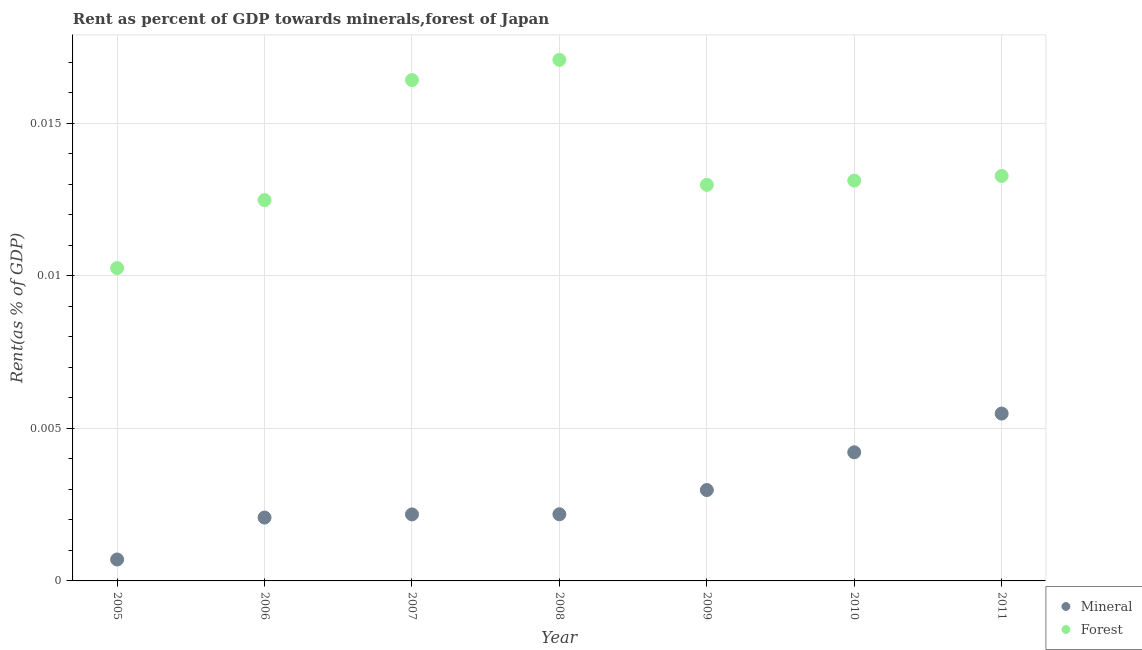What is the mineral rent in 2009?
Your answer should be very brief. 0. Across all years, what is the maximum mineral rent?
Keep it short and to the point. 0.01. Across all years, what is the minimum mineral rent?
Your response must be concise. 0. In which year was the mineral rent minimum?
Offer a terse response. 2005. What is the total forest rent in the graph?
Provide a succinct answer. 0.1. What is the difference between the forest rent in 2007 and that in 2010?
Your answer should be compact. 0. What is the difference between the forest rent in 2011 and the mineral rent in 2005?
Your answer should be compact. 0.01. What is the average mineral rent per year?
Provide a succinct answer. 0. In the year 2006, what is the difference between the forest rent and mineral rent?
Ensure brevity in your answer.  0.01. In how many years, is the forest rent greater than 0.007 %?
Make the answer very short. 7. What is the ratio of the forest rent in 2006 to that in 2011?
Your response must be concise. 0.94. Is the forest rent in 2007 less than that in 2009?
Provide a succinct answer. No. Is the difference between the mineral rent in 2008 and 2011 greater than the difference between the forest rent in 2008 and 2011?
Make the answer very short. No. What is the difference between the highest and the second highest mineral rent?
Provide a short and direct response. 0. What is the difference between the highest and the lowest forest rent?
Your answer should be very brief. 0.01. Does the mineral rent monotonically increase over the years?
Offer a very short reply. Yes. Is the mineral rent strictly greater than the forest rent over the years?
Offer a very short reply. No. How many years are there in the graph?
Give a very brief answer. 7. What is the difference between two consecutive major ticks on the Y-axis?
Provide a short and direct response. 0.01. Are the values on the major ticks of Y-axis written in scientific E-notation?
Provide a succinct answer. No. Does the graph contain any zero values?
Give a very brief answer. No. Does the graph contain grids?
Ensure brevity in your answer.  Yes. What is the title of the graph?
Your answer should be very brief. Rent as percent of GDP towards minerals,forest of Japan. Does "Agricultural land" appear as one of the legend labels in the graph?
Offer a terse response. No. What is the label or title of the X-axis?
Offer a terse response. Year. What is the label or title of the Y-axis?
Your answer should be very brief. Rent(as % of GDP). What is the Rent(as % of GDP) of Mineral in 2005?
Your answer should be very brief. 0. What is the Rent(as % of GDP) in Forest in 2005?
Your answer should be very brief. 0.01. What is the Rent(as % of GDP) of Mineral in 2006?
Offer a terse response. 0. What is the Rent(as % of GDP) of Forest in 2006?
Your answer should be very brief. 0.01. What is the Rent(as % of GDP) in Mineral in 2007?
Your answer should be very brief. 0. What is the Rent(as % of GDP) of Forest in 2007?
Your answer should be very brief. 0.02. What is the Rent(as % of GDP) of Mineral in 2008?
Your response must be concise. 0. What is the Rent(as % of GDP) of Forest in 2008?
Make the answer very short. 0.02. What is the Rent(as % of GDP) of Mineral in 2009?
Ensure brevity in your answer.  0. What is the Rent(as % of GDP) in Forest in 2009?
Provide a short and direct response. 0.01. What is the Rent(as % of GDP) of Mineral in 2010?
Give a very brief answer. 0. What is the Rent(as % of GDP) of Forest in 2010?
Provide a short and direct response. 0.01. What is the Rent(as % of GDP) of Mineral in 2011?
Offer a terse response. 0.01. What is the Rent(as % of GDP) in Forest in 2011?
Give a very brief answer. 0.01. Across all years, what is the maximum Rent(as % of GDP) in Mineral?
Offer a very short reply. 0.01. Across all years, what is the maximum Rent(as % of GDP) in Forest?
Provide a short and direct response. 0.02. Across all years, what is the minimum Rent(as % of GDP) in Mineral?
Keep it short and to the point. 0. Across all years, what is the minimum Rent(as % of GDP) in Forest?
Your answer should be very brief. 0.01. What is the total Rent(as % of GDP) in Mineral in the graph?
Your response must be concise. 0.02. What is the total Rent(as % of GDP) in Forest in the graph?
Make the answer very short. 0.1. What is the difference between the Rent(as % of GDP) in Mineral in 2005 and that in 2006?
Ensure brevity in your answer.  -0. What is the difference between the Rent(as % of GDP) in Forest in 2005 and that in 2006?
Provide a succinct answer. -0. What is the difference between the Rent(as % of GDP) in Mineral in 2005 and that in 2007?
Your response must be concise. -0. What is the difference between the Rent(as % of GDP) of Forest in 2005 and that in 2007?
Offer a terse response. -0.01. What is the difference between the Rent(as % of GDP) in Mineral in 2005 and that in 2008?
Your response must be concise. -0. What is the difference between the Rent(as % of GDP) in Forest in 2005 and that in 2008?
Offer a terse response. -0.01. What is the difference between the Rent(as % of GDP) in Mineral in 2005 and that in 2009?
Provide a succinct answer. -0. What is the difference between the Rent(as % of GDP) in Forest in 2005 and that in 2009?
Give a very brief answer. -0. What is the difference between the Rent(as % of GDP) in Mineral in 2005 and that in 2010?
Provide a succinct answer. -0. What is the difference between the Rent(as % of GDP) of Forest in 2005 and that in 2010?
Your response must be concise. -0. What is the difference between the Rent(as % of GDP) of Mineral in 2005 and that in 2011?
Make the answer very short. -0. What is the difference between the Rent(as % of GDP) in Forest in 2005 and that in 2011?
Your answer should be compact. -0. What is the difference between the Rent(as % of GDP) of Mineral in 2006 and that in 2007?
Your answer should be very brief. -0. What is the difference between the Rent(as % of GDP) in Forest in 2006 and that in 2007?
Make the answer very short. -0. What is the difference between the Rent(as % of GDP) of Mineral in 2006 and that in 2008?
Provide a succinct answer. -0. What is the difference between the Rent(as % of GDP) of Forest in 2006 and that in 2008?
Offer a very short reply. -0. What is the difference between the Rent(as % of GDP) of Mineral in 2006 and that in 2009?
Your response must be concise. -0. What is the difference between the Rent(as % of GDP) of Forest in 2006 and that in 2009?
Your answer should be compact. -0. What is the difference between the Rent(as % of GDP) of Mineral in 2006 and that in 2010?
Offer a very short reply. -0. What is the difference between the Rent(as % of GDP) in Forest in 2006 and that in 2010?
Your answer should be very brief. -0. What is the difference between the Rent(as % of GDP) of Mineral in 2006 and that in 2011?
Provide a succinct answer. -0. What is the difference between the Rent(as % of GDP) in Forest in 2006 and that in 2011?
Give a very brief answer. -0. What is the difference between the Rent(as % of GDP) of Mineral in 2007 and that in 2008?
Offer a terse response. -0. What is the difference between the Rent(as % of GDP) in Forest in 2007 and that in 2008?
Your response must be concise. -0. What is the difference between the Rent(as % of GDP) in Mineral in 2007 and that in 2009?
Offer a very short reply. -0. What is the difference between the Rent(as % of GDP) in Forest in 2007 and that in 2009?
Your answer should be very brief. 0. What is the difference between the Rent(as % of GDP) of Mineral in 2007 and that in 2010?
Ensure brevity in your answer.  -0. What is the difference between the Rent(as % of GDP) of Forest in 2007 and that in 2010?
Your answer should be compact. 0. What is the difference between the Rent(as % of GDP) in Mineral in 2007 and that in 2011?
Your answer should be compact. -0. What is the difference between the Rent(as % of GDP) of Forest in 2007 and that in 2011?
Ensure brevity in your answer.  0. What is the difference between the Rent(as % of GDP) in Mineral in 2008 and that in 2009?
Provide a succinct answer. -0. What is the difference between the Rent(as % of GDP) of Forest in 2008 and that in 2009?
Offer a very short reply. 0. What is the difference between the Rent(as % of GDP) of Mineral in 2008 and that in 2010?
Give a very brief answer. -0. What is the difference between the Rent(as % of GDP) of Forest in 2008 and that in 2010?
Your answer should be very brief. 0. What is the difference between the Rent(as % of GDP) in Mineral in 2008 and that in 2011?
Ensure brevity in your answer.  -0. What is the difference between the Rent(as % of GDP) in Forest in 2008 and that in 2011?
Offer a very short reply. 0. What is the difference between the Rent(as % of GDP) of Mineral in 2009 and that in 2010?
Your answer should be compact. -0. What is the difference between the Rent(as % of GDP) of Forest in 2009 and that in 2010?
Your answer should be compact. -0. What is the difference between the Rent(as % of GDP) in Mineral in 2009 and that in 2011?
Give a very brief answer. -0. What is the difference between the Rent(as % of GDP) in Forest in 2009 and that in 2011?
Keep it short and to the point. -0. What is the difference between the Rent(as % of GDP) of Mineral in 2010 and that in 2011?
Offer a very short reply. -0. What is the difference between the Rent(as % of GDP) in Forest in 2010 and that in 2011?
Your answer should be very brief. -0. What is the difference between the Rent(as % of GDP) of Mineral in 2005 and the Rent(as % of GDP) of Forest in 2006?
Give a very brief answer. -0.01. What is the difference between the Rent(as % of GDP) of Mineral in 2005 and the Rent(as % of GDP) of Forest in 2007?
Offer a terse response. -0.02. What is the difference between the Rent(as % of GDP) of Mineral in 2005 and the Rent(as % of GDP) of Forest in 2008?
Ensure brevity in your answer.  -0.02. What is the difference between the Rent(as % of GDP) of Mineral in 2005 and the Rent(as % of GDP) of Forest in 2009?
Give a very brief answer. -0.01. What is the difference between the Rent(as % of GDP) in Mineral in 2005 and the Rent(as % of GDP) in Forest in 2010?
Your answer should be compact. -0.01. What is the difference between the Rent(as % of GDP) in Mineral in 2005 and the Rent(as % of GDP) in Forest in 2011?
Offer a terse response. -0.01. What is the difference between the Rent(as % of GDP) of Mineral in 2006 and the Rent(as % of GDP) of Forest in 2007?
Provide a short and direct response. -0.01. What is the difference between the Rent(as % of GDP) of Mineral in 2006 and the Rent(as % of GDP) of Forest in 2008?
Keep it short and to the point. -0.01. What is the difference between the Rent(as % of GDP) in Mineral in 2006 and the Rent(as % of GDP) in Forest in 2009?
Your answer should be very brief. -0.01. What is the difference between the Rent(as % of GDP) in Mineral in 2006 and the Rent(as % of GDP) in Forest in 2010?
Provide a short and direct response. -0.01. What is the difference between the Rent(as % of GDP) in Mineral in 2006 and the Rent(as % of GDP) in Forest in 2011?
Ensure brevity in your answer.  -0.01. What is the difference between the Rent(as % of GDP) in Mineral in 2007 and the Rent(as % of GDP) in Forest in 2008?
Your answer should be very brief. -0.01. What is the difference between the Rent(as % of GDP) in Mineral in 2007 and the Rent(as % of GDP) in Forest in 2009?
Provide a short and direct response. -0.01. What is the difference between the Rent(as % of GDP) of Mineral in 2007 and the Rent(as % of GDP) of Forest in 2010?
Give a very brief answer. -0.01. What is the difference between the Rent(as % of GDP) of Mineral in 2007 and the Rent(as % of GDP) of Forest in 2011?
Your answer should be compact. -0.01. What is the difference between the Rent(as % of GDP) of Mineral in 2008 and the Rent(as % of GDP) of Forest in 2009?
Provide a short and direct response. -0.01. What is the difference between the Rent(as % of GDP) of Mineral in 2008 and the Rent(as % of GDP) of Forest in 2010?
Offer a terse response. -0.01. What is the difference between the Rent(as % of GDP) of Mineral in 2008 and the Rent(as % of GDP) of Forest in 2011?
Offer a very short reply. -0.01. What is the difference between the Rent(as % of GDP) in Mineral in 2009 and the Rent(as % of GDP) in Forest in 2010?
Keep it short and to the point. -0.01. What is the difference between the Rent(as % of GDP) in Mineral in 2009 and the Rent(as % of GDP) in Forest in 2011?
Offer a terse response. -0.01. What is the difference between the Rent(as % of GDP) of Mineral in 2010 and the Rent(as % of GDP) of Forest in 2011?
Your answer should be compact. -0.01. What is the average Rent(as % of GDP) of Mineral per year?
Offer a very short reply. 0. What is the average Rent(as % of GDP) of Forest per year?
Provide a succinct answer. 0.01. In the year 2005, what is the difference between the Rent(as % of GDP) of Mineral and Rent(as % of GDP) of Forest?
Give a very brief answer. -0.01. In the year 2006, what is the difference between the Rent(as % of GDP) in Mineral and Rent(as % of GDP) in Forest?
Keep it short and to the point. -0.01. In the year 2007, what is the difference between the Rent(as % of GDP) in Mineral and Rent(as % of GDP) in Forest?
Your answer should be compact. -0.01. In the year 2008, what is the difference between the Rent(as % of GDP) in Mineral and Rent(as % of GDP) in Forest?
Your answer should be very brief. -0.01. In the year 2009, what is the difference between the Rent(as % of GDP) in Mineral and Rent(as % of GDP) in Forest?
Your answer should be compact. -0.01. In the year 2010, what is the difference between the Rent(as % of GDP) in Mineral and Rent(as % of GDP) in Forest?
Offer a terse response. -0.01. In the year 2011, what is the difference between the Rent(as % of GDP) of Mineral and Rent(as % of GDP) of Forest?
Your answer should be very brief. -0.01. What is the ratio of the Rent(as % of GDP) in Mineral in 2005 to that in 2006?
Your response must be concise. 0.34. What is the ratio of the Rent(as % of GDP) in Forest in 2005 to that in 2006?
Ensure brevity in your answer.  0.82. What is the ratio of the Rent(as % of GDP) in Mineral in 2005 to that in 2007?
Offer a very short reply. 0.32. What is the ratio of the Rent(as % of GDP) in Forest in 2005 to that in 2007?
Your response must be concise. 0.62. What is the ratio of the Rent(as % of GDP) of Mineral in 2005 to that in 2008?
Offer a terse response. 0.32. What is the ratio of the Rent(as % of GDP) in Forest in 2005 to that in 2008?
Provide a short and direct response. 0.6. What is the ratio of the Rent(as % of GDP) in Mineral in 2005 to that in 2009?
Make the answer very short. 0.24. What is the ratio of the Rent(as % of GDP) in Forest in 2005 to that in 2009?
Keep it short and to the point. 0.79. What is the ratio of the Rent(as % of GDP) of Mineral in 2005 to that in 2010?
Provide a short and direct response. 0.17. What is the ratio of the Rent(as % of GDP) in Forest in 2005 to that in 2010?
Offer a very short reply. 0.78. What is the ratio of the Rent(as % of GDP) of Mineral in 2005 to that in 2011?
Offer a very short reply. 0.13. What is the ratio of the Rent(as % of GDP) of Forest in 2005 to that in 2011?
Provide a succinct answer. 0.77. What is the ratio of the Rent(as % of GDP) of Mineral in 2006 to that in 2007?
Offer a very short reply. 0.95. What is the ratio of the Rent(as % of GDP) of Forest in 2006 to that in 2007?
Your response must be concise. 0.76. What is the ratio of the Rent(as % of GDP) of Mineral in 2006 to that in 2008?
Offer a terse response. 0.95. What is the ratio of the Rent(as % of GDP) of Forest in 2006 to that in 2008?
Your response must be concise. 0.73. What is the ratio of the Rent(as % of GDP) of Mineral in 2006 to that in 2009?
Offer a terse response. 0.7. What is the ratio of the Rent(as % of GDP) of Forest in 2006 to that in 2009?
Your answer should be very brief. 0.96. What is the ratio of the Rent(as % of GDP) in Mineral in 2006 to that in 2010?
Make the answer very short. 0.49. What is the ratio of the Rent(as % of GDP) of Forest in 2006 to that in 2010?
Give a very brief answer. 0.95. What is the ratio of the Rent(as % of GDP) of Mineral in 2006 to that in 2011?
Provide a succinct answer. 0.38. What is the ratio of the Rent(as % of GDP) of Forest in 2006 to that in 2011?
Offer a very short reply. 0.94. What is the ratio of the Rent(as % of GDP) of Forest in 2007 to that in 2008?
Your answer should be very brief. 0.96. What is the ratio of the Rent(as % of GDP) in Mineral in 2007 to that in 2009?
Your response must be concise. 0.73. What is the ratio of the Rent(as % of GDP) in Forest in 2007 to that in 2009?
Keep it short and to the point. 1.26. What is the ratio of the Rent(as % of GDP) in Mineral in 2007 to that in 2010?
Offer a terse response. 0.52. What is the ratio of the Rent(as % of GDP) in Forest in 2007 to that in 2010?
Provide a succinct answer. 1.25. What is the ratio of the Rent(as % of GDP) in Mineral in 2007 to that in 2011?
Keep it short and to the point. 0.4. What is the ratio of the Rent(as % of GDP) of Forest in 2007 to that in 2011?
Give a very brief answer. 1.24. What is the ratio of the Rent(as % of GDP) of Mineral in 2008 to that in 2009?
Your answer should be compact. 0.73. What is the ratio of the Rent(as % of GDP) of Forest in 2008 to that in 2009?
Provide a succinct answer. 1.32. What is the ratio of the Rent(as % of GDP) of Mineral in 2008 to that in 2010?
Provide a short and direct response. 0.52. What is the ratio of the Rent(as % of GDP) in Forest in 2008 to that in 2010?
Ensure brevity in your answer.  1.3. What is the ratio of the Rent(as % of GDP) in Mineral in 2008 to that in 2011?
Ensure brevity in your answer.  0.4. What is the ratio of the Rent(as % of GDP) in Forest in 2008 to that in 2011?
Your answer should be compact. 1.29. What is the ratio of the Rent(as % of GDP) in Mineral in 2009 to that in 2010?
Your answer should be compact. 0.71. What is the ratio of the Rent(as % of GDP) in Mineral in 2009 to that in 2011?
Offer a very short reply. 0.54. What is the ratio of the Rent(as % of GDP) in Forest in 2009 to that in 2011?
Your answer should be compact. 0.98. What is the ratio of the Rent(as % of GDP) in Mineral in 2010 to that in 2011?
Your answer should be compact. 0.77. What is the ratio of the Rent(as % of GDP) in Forest in 2010 to that in 2011?
Offer a terse response. 0.99. What is the difference between the highest and the second highest Rent(as % of GDP) of Mineral?
Your answer should be compact. 0. What is the difference between the highest and the second highest Rent(as % of GDP) of Forest?
Ensure brevity in your answer.  0. What is the difference between the highest and the lowest Rent(as % of GDP) in Mineral?
Your answer should be very brief. 0. What is the difference between the highest and the lowest Rent(as % of GDP) of Forest?
Keep it short and to the point. 0.01. 